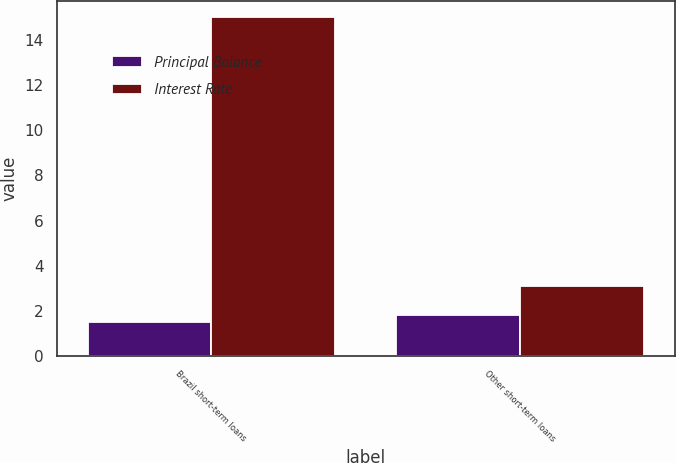Convert chart to OTSL. <chart><loc_0><loc_0><loc_500><loc_500><stacked_bar_chart><ecel><fcel>Brazil short-term loans<fcel>Other short-term loans<nl><fcel>Principal Balance<fcel>1.5<fcel>1.8<nl><fcel>Interest Rate<fcel>15<fcel>3.1<nl></chart> 